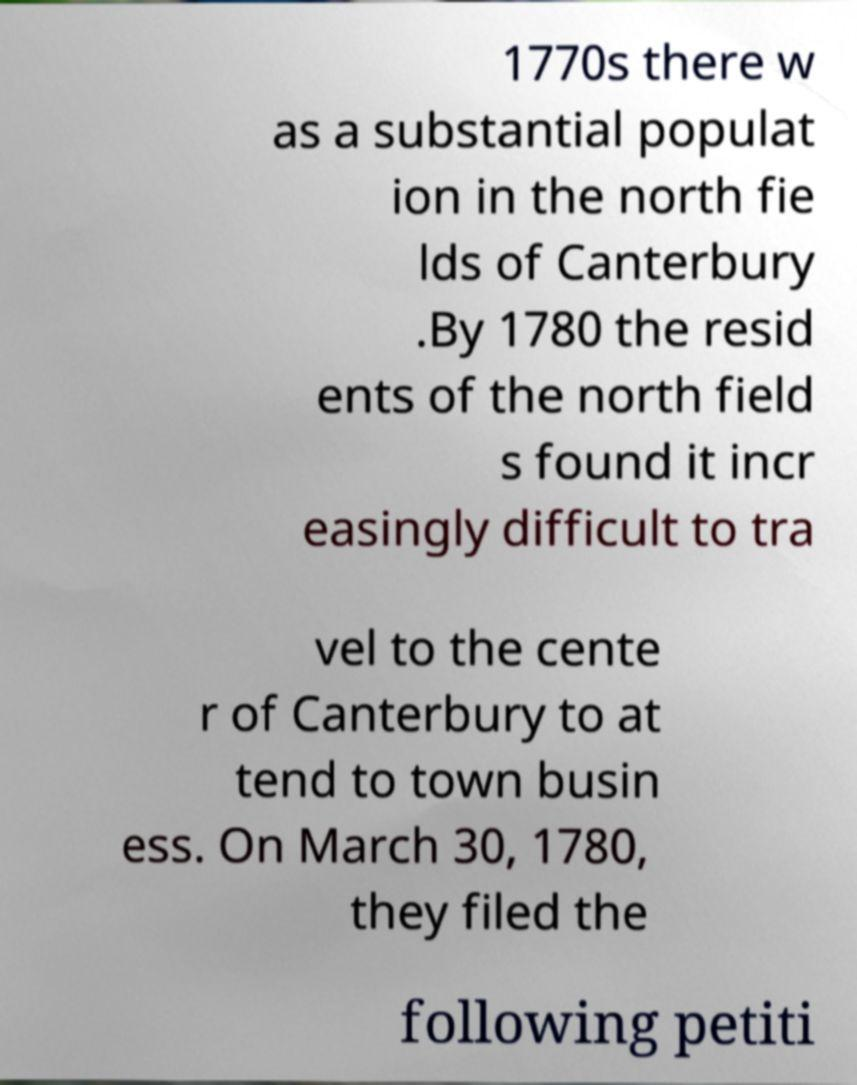Could you assist in decoding the text presented in this image and type it out clearly? 1770s there w as a substantial populat ion in the north fie lds of Canterbury .By 1780 the resid ents of the north field s found it incr easingly difficult to tra vel to the cente r of Canterbury to at tend to town busin ess. On March 30, 1780, they filed the following petiti 